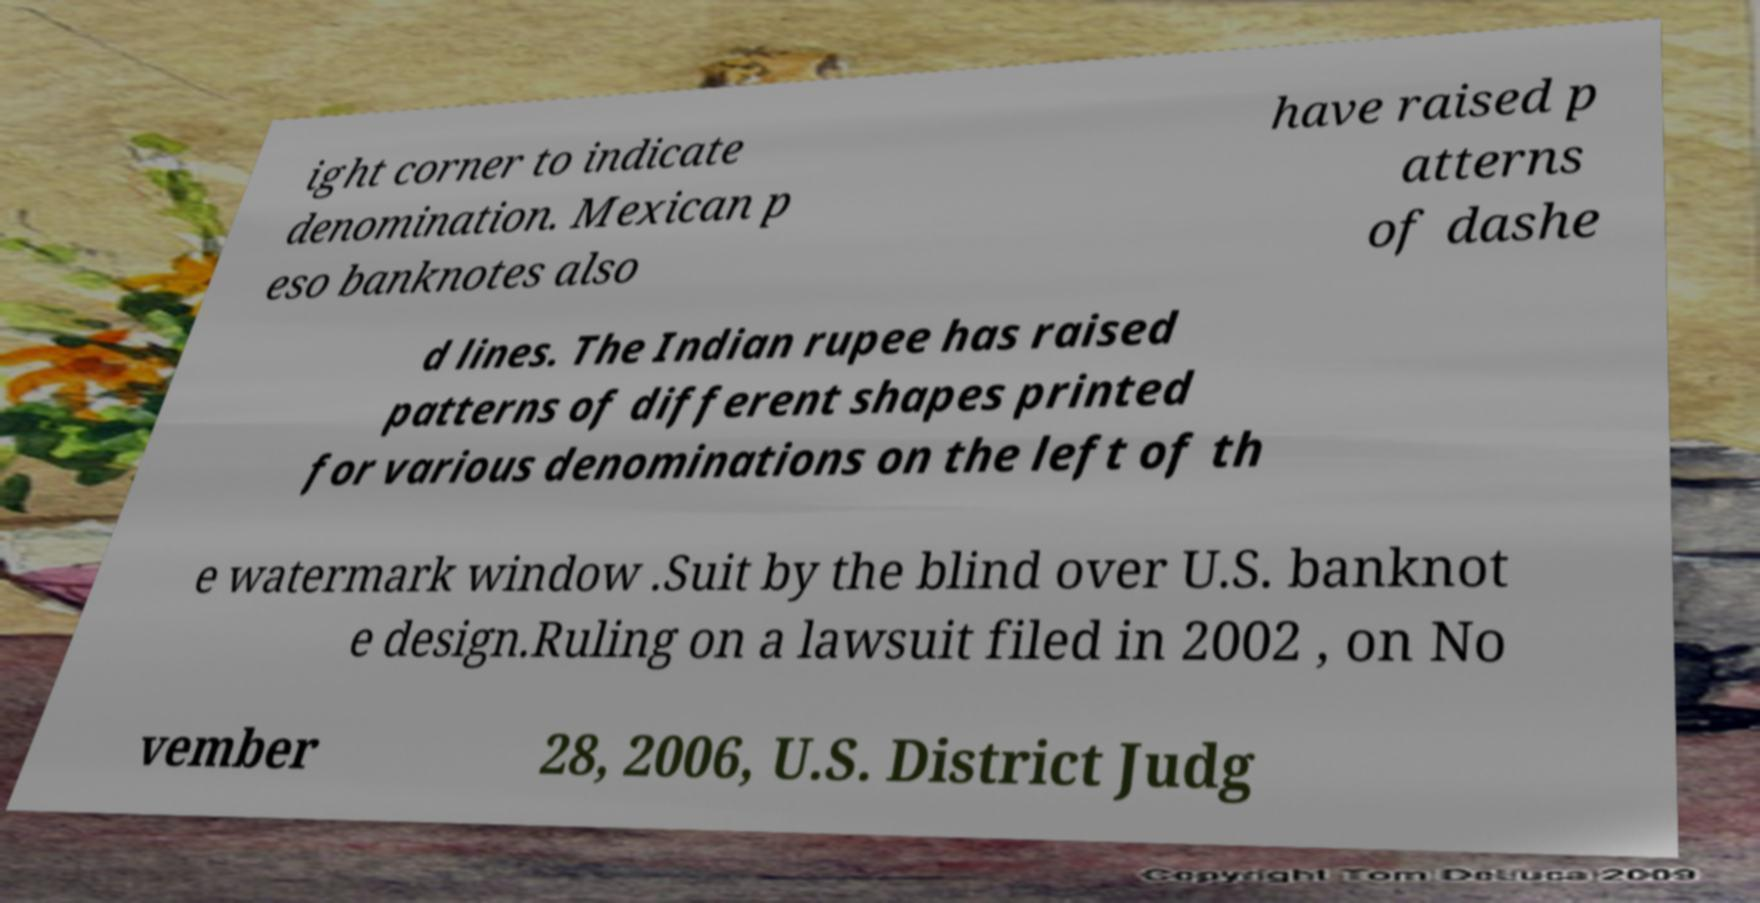Can you read and provide the text displayed in the image?This photo seems to have some interesting text. Can you extract and type it out for me? ight corner to indicate denomination. Mexican p eso banknotes also have raised p atterns of dashe d lines. The Indian rupee has raised patterns of different shapes printed for various denominations on the left of th e watermark window .Suit by the blind over U.S. banknot e design.Ruling on a lawsuit filed in 2002 , on No vember 28, 2006, U.S. District Judg 